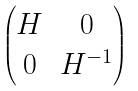<formula> <loc_0><loc_0><loc_500><loc_500>\begin{pmatrix} H & 0 \\ 0 & H ^ { - 1 } \end{pmatrix}</formula> 